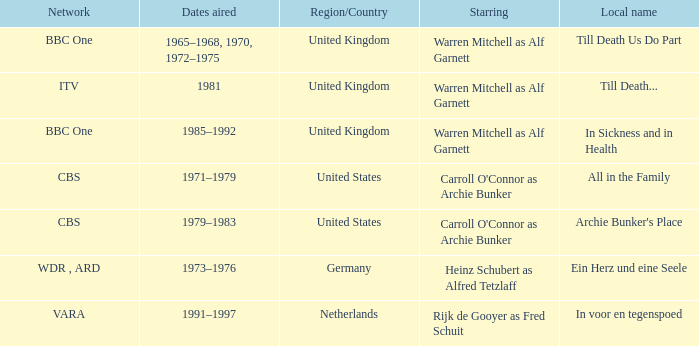What is the local name for the episodes that aired in 1981? Till Death... 